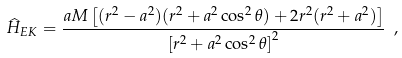<formula> <loc_0><loc_0><loc_500><loc_500>\widehat { H } _ { E K } = \frac { a M \left [ ( r ^ { 2 } - a ^ { 2 } ) ( r ^ { 2 } + a ^ { 2 } \cos ^ { 2 } \theta ) + 2 r ^ { 2 } ( r ^ { 2 } + a ^ { 2 } ) \right ] } { \left [ r ^ { 2 } + a ^ { 2 } \cos ^ { 2 } \theta \right ] ^ { 2 } } \ ,</formula> 